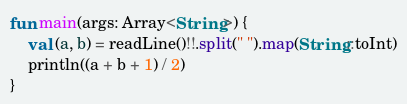Convert code to text. <code><loc_0><loc_0><loc_500><loc_500><_Kotlin_>fun main(args: Array<String>) {
    val (a, b) = readLine()!!.split(" ").map(String::toInt)
    println((a + b + 1) / 2)
}</code> 